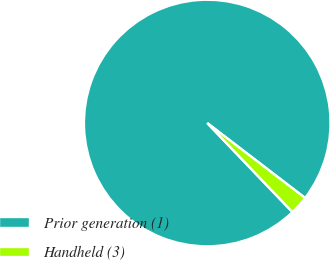Convert chart to OTSL. <chart><loc_0><loc_0><loc_500><loc_500><pie_chart><fcel>Prior generation (1)<fcel>Handheld (3)<nl><fcel>97.55%<fcel>2.45%<nl></chart> 